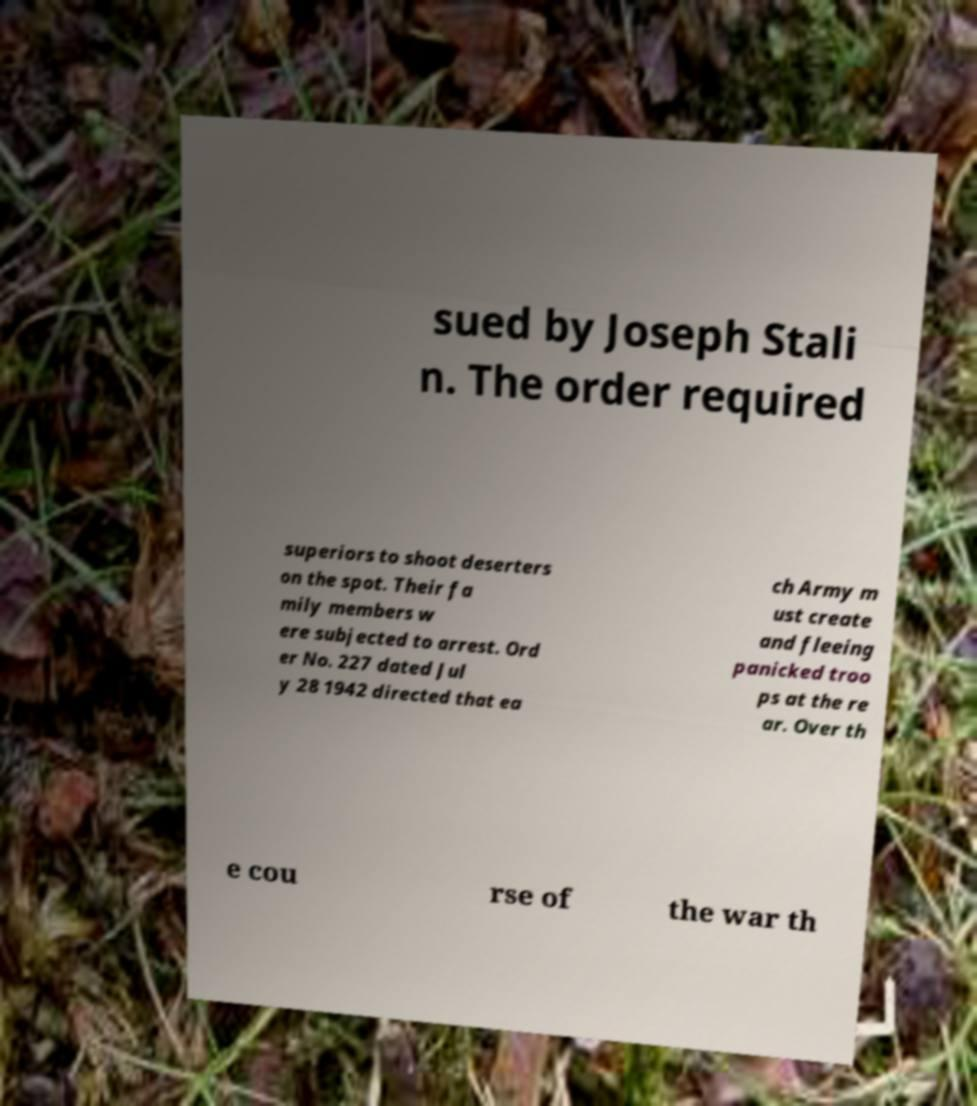There's text embedded in this image that I need extracted. Can you transcribe it verbatim? sued by Joseph Stali n. The order required superiors to shoot deserters on the spot. Their fa mily members w ere subjected to arrest. Ord er No. 227 dated Jul y 28 1942 directed that ea ch Army m ust create and fleeing panicked troo ps at the re ar. Over th e cou rse of the war th 